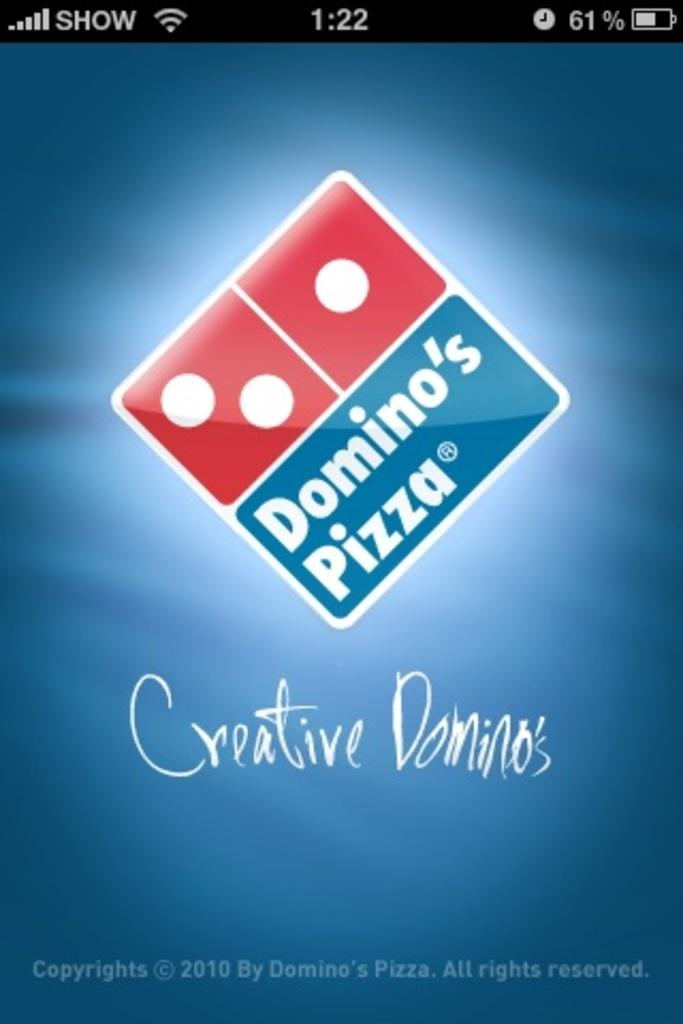Provide a one-sentence caption for the provided image. A phone screen shot that shows a Domino's Pizza ad. 